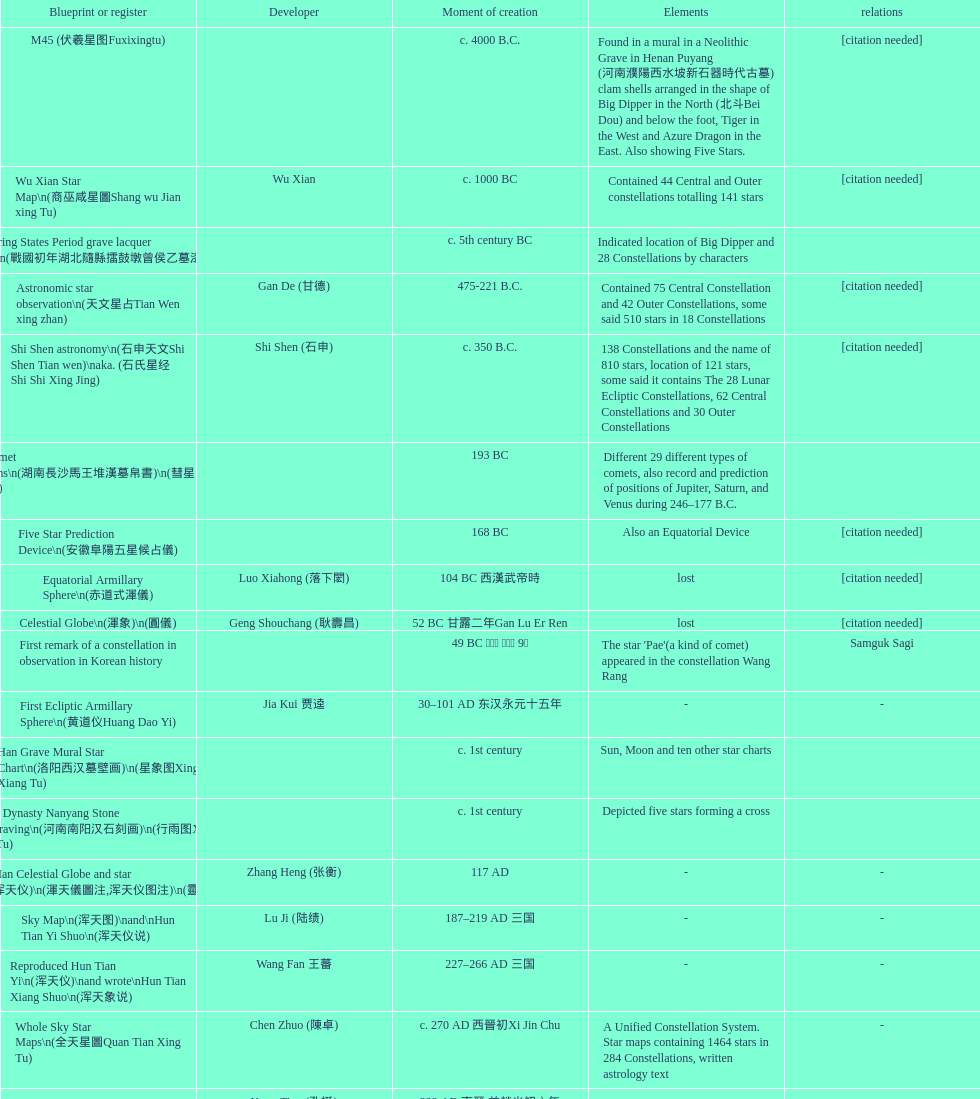Which map or catalog was created last? Sky in Google Earth KML. 